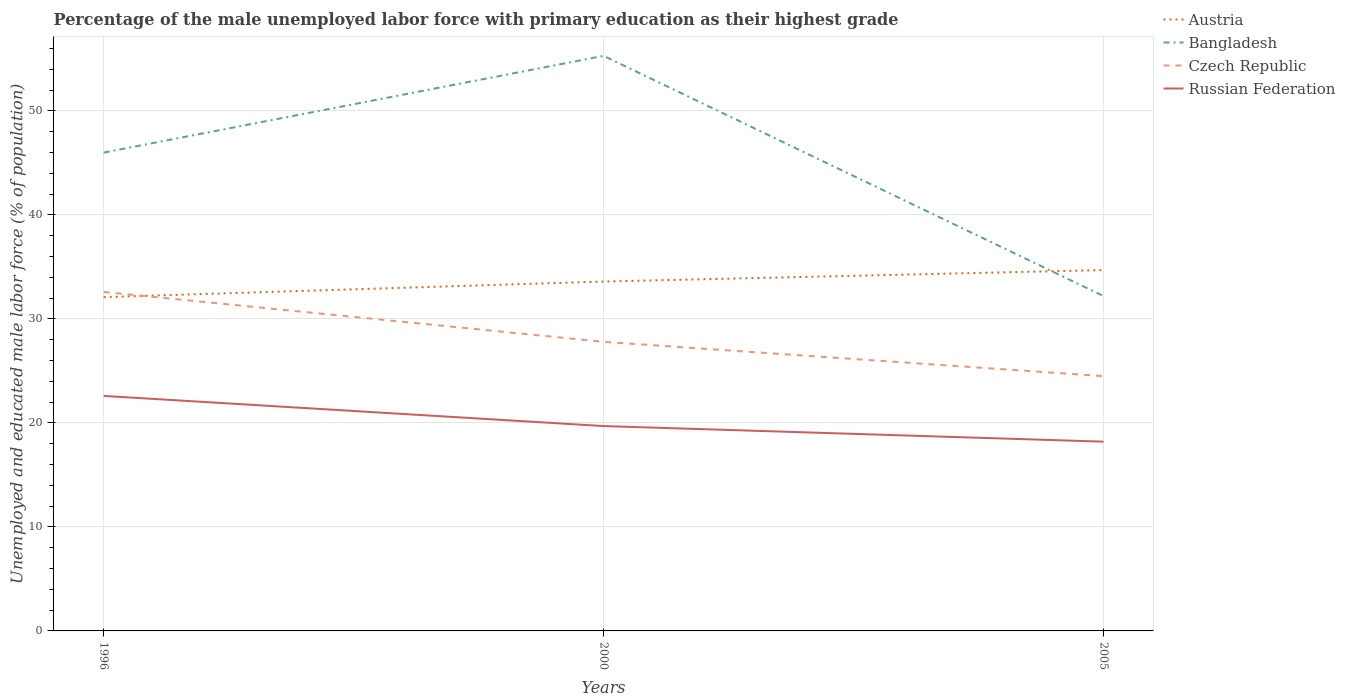How many different coloured lines are there?
Keep it short and to the point. 4. Does the line corresponding to Czech Republic intersect with the line corresponding to Austria?
Give a very brief answer. Yes. Across all years, what is the maximum percentage of the unemployed male labor force with primary education in Austria?
Your answer should be very brief. 32.1. What is the total percentage of the unemployed male labor force with primary education in Austria in the graph?
Your response must be concise. -2.6. What is the difference between the highest and the second highest percentage of the unemployed male labor force with primary education in Austria?
Keep it short and to the point. 2.6. What is the difference between the highest and the lowest percentage of the unemployed male labor force with primary education in Bangladesh?
Your response must be concise. 2. Is the percentage of the unemployed male labor force with primary education in Bangladesh strictly greater than the percentage of the unemployed male labor force with primary education in Austria over the years?
Your answer should be very brief. No. How many lines are there?
Provide a short and direct response. 4. How many years are there in the graph?
Your response must be concise. 3. What is the difference between two consecutive major ticks on the Y-axis?
Your answer should be very brief. 10. Does the graph contain grids?
Provide a short and direct response. Yes. How are the legend labels stacked?
Make the answer very short. Vertical. What is the title of the graph?
Provide a succinct answer. Percentage of the male unemployed labor force with primary education as their highest grade. What is the label or title of the X-axis?
Offer a terse response. Years. What is the label or title of the Y-axis?
Your response must be concise. Unemployed and educated male labor force (% of population). What is the Unemployed and educated male labor force (% of population) in Austria in 1996?
Your answer should be compact. 32.1. What is the Unemployed and educated male labor force (% of population) in Czech Republic in 1996?
Offer a terse response. 32.6. What is the Unemployed and educated male labor force (% of population) in Russian Federation in 1996?
Provide a succinct answer. 22.6. What is the Unemployed and educated male labor force (% of population) of Austria in 2000?
Provide a short and direct response. 33.6. What is the Unemployed and educated male labor force (% of population) in Bangladesh in 2000?
Keep it short and to the point. 55.3. What is the Unemployed and educated male labor force (% of population) in Czech Republic in 2000?
Your response must be concise. 27.8. What is the Unemployed and educated male labor force (% of population) of Russian Federation in 2000?
Ensure brevity in your answer.  19.7. What is the Unemployed and educated male labor force (% of population) in Austria in 2005?
Offer a very short reply. 34.7. What is the Unemployed and educated male labor force (% of population) in Bangladesh in 2005?
Ensure brevity in your answer.  32.2. What is the Unemployed and educated male labor force (% of population) of Czech Republic in 2005?
Make the answer very short. 24.5. What is the Unemployed and educated male labor force (% of population) of Russian Federation in 2005?
Provide a succinct answer. 18.2. Across all years, what is the maximum Unemployed and educated male labor force (% of population) of Austria?
Give a very brief answer. 34.7. Across all years, what is the maximum Unemployed and educated male labor force (% of population) of Bangladesh?
Your answer should be compact. 55.3. Across all years, what is the maximum Unemployed and educated male labor force (% of population) in Czech Republic?
Provide a short and direct response. 32.6. Across all years, what is the maximum Unemployed and educated male labor force (% of population) of Russian Federation?
Offer a terse response. 22.6. Across all years, what is the minimum Unemployed and educated male labor force (% of population) of Austria?
Make the answer very short. 32.1. Across all years, what is the minimum Unemployed and educated male labor force (% of population) in Bangladesh?
Make the answer very short. 32.2. Across all years, what is the minimum Unemployed and educated male labor force (% of population) of Russian Federation?
Your answer should be compact. 18.2. What is the total Unemployed and educated male labor force (% of population) in Austria in the graph?
Offer a terse response. 100.4. What is the total Unemployed and educated male labor force (% of population) in Bangladesh in the graph?
Offer a terse response. 133.5. What is the total Unemployed and educated male labor force (% of population) of Czech Republic in the graph?
Give a very brief answer. 84.9. What is the total Unemployed and educated male labor force (% of population) in Russian Federation in the graph?
Offer a terse response. 60.5. What is the difference between the Unemployed and educated male labor force (% of population) of Austria in 1996 and that in 2000?
Make the answer very short. -1.5. What is the difference between the Unemployed and educated male labor force (% of population) of Russian Federation in 1996 and that in 2000?
Give a very brief answer. 2.9. What is the difference between the Unemployed and educated male labor force (% of population) in Austria in 1996 and that in 2005?
Make the answer very short. -2.6. What is the difference between the Unemployed and educated male labor force (% of population) in Russian Federation in 1996 and that in 2005?
Keep it short and to the point. 4.4. What is the difference between the Unemployed and educated male labor force (% of population) of Austria in 2000 and that in 2005?
Keep it short and to the point. -1.1. What is the difference between the Unemployed and educated male labor force (% of population) in Bangladesh in 2000 and that in 2005?
Ensure brevity in your answer.  23.1. What is the difference between the Unemployed and educated male labor force (% of population) in Czech Republic in 2000 and that in 2005?
Keep it short and to the point. 3.3. What is the difference between the Unemployed and educated male labor force (% of population) in Russian Federation in 2000 and that in 2005?
Ensure brevity in your answer.  1.5. What is the difference between the Unemployed and educated male labor force (% of population) of Austria in 1996 and the Unemployed and educated male labor force (% of population) of Bangladesh in 2000?
Give a very brief answer. -23.2. What is the difference between the Unemployed and educated male labor force (% of population) in Austria in 1996 and the Unemployed and educated male labor force (% of population) in Czech Republic in 2000?
Offer a terse response. 4.3. What is the difference between the Unemployed and educated male labor force (% of population) in Austria in 1996 and the Unemployed and educated male labor force (% of population) in Russian Federation in 2000?
Provide a short and direct response. 12.4. What is the difference between the Unemployed and educated male labor force (% of population) in Bangladesh in 1996 and the Unemployed and educated male labor force (% of population) in Czech Republic in 2000?
Provide a short and direct response. 18.2. What is the difference between the Unemployed and educated male labor force (% of population) of Bangladesh in 1996 and the Unemployed and educated male labor force (% of population) of Russian Federation in 2000?
Your answer should be compact. 26.3. What is the difference between the Unemployed and educated male labor force (% of population) in Czech Republic in 1996 and the Unemployed and educated male labor force (% of population) in Russian Federation in 2000?
Provide a succinct answer. 12.9. What is the difference between the Unemployed and educated male labor force (% of population) in Austria in 1996 and the Unemployed and educated male labor force (% of population) in Bangladesh in 2005?
Offer a terse response. -0.1. What is the difference between the Unemployed and educated male labor force (% of population) in Bangladesh in 1996 and the Unemployed and educated male labor force (% of population) in Czech Republic in 2005?
Provide a succinct answer. 21.5. What is the difference between the Unemployed and educated male labor force (% of population) in Bangladesh in 1996 and the Unemployed and educated male labor force (% of population) in Russian Federation in 2005?
Offer a very short reply. 27.8. What is the difference between the Unemployed and educated male labor force (% of population) of Czech Republic in 1996 and the Unemployed and educated male labor force (% of population) of Russian Federation in 2005?
Your answer should be compact. 14.4. What is the difference between the Unemployed and educated male labor force (% of population) in Austria in 2000 and the Unemployed and educated male labor force (% of population) in Czech Republic in 2005?
Keep it short and to the point. 9.1. What is the difference between the Unemployed and educated male labor force (% of population) in Bangladesh in 2000 and the Unemployed and educated male labor force (% of population) in Czech Republic in 2005?
Keep it short and to the point. 30.8. What is the difference between the Unemployed and educated male labor force (% of population) in Bangladesh in 2000 and the Unemployed and educated male labor force (% of population) in Russian Federation in 2005?
Ensure brevity in your answer.  37.1. What is the average Unemployed and educated male labor force (% of population) in Austria per year?
Your answer should be compact. 33.47. What is the average Unemployed and educated male labor force (% of population) of Bangladesh per year?
Give a very brief answer. 44.5. What is the average Unemployed and educated male labor force (% of population) in Czech Republic per year?
Make the answer very short. 28.3. What is the average Unemployed and educated male labor force (% of population) of Russian Federation per year?
Keep it short and to the point. 20.17. In the year 1996, what is the difference between the Unemployed and educated male labor force (% of population) of Austria and Unemployed and educated male labor force (% of population) of Bangladesh?
Offer a very short reply. -13.9. In the year 1996, what is the difference between the Unemployed and educated male labor force (% of population) in Bangladesh and Unemployed and educated male labor force (% of population) in Russian Federation?
Your answer should be compact. 23.4. In the year 2000, what is the difference between the Unemployed and educated male labor force (% of population) in Austria and Unemployed and educated male labor force (% of population) in Bangladesh?
Give a very brief answer. -21.7. In the year 2000, what is the difference between the Unemployed and educated male labor force (% of population) in Austria and Unemployed and educated male labor force (% of population) in Czech Republic?
Ensure brevity in your answer.  5.8. In the year 2000, what is the difference between the Unemployed and educated male labor force (% of population) of Bangladesh and Unemployed and educated male labor force (% of population) of Russian Federation?
Keep it short and to the point. 35.6. In the year 2005, what is the difference between the Unemployed and educated male labor force (% of population) in Bangladesh and Unemployed and educated male labor force (% of population) in Czech Republic?
Give a very brief answer. 7.7. In the year 2005, what is the difference between the Unemployed and educated male labor force (% of population) in Bangladesh and Unemployed and educated male labor force (% of population) in Russian Federation?
Your response must be concise. 14. In the year 2005, what is the difference between the Unemployed and educated male labor force (% of population) of Czech Republic and Unemployed and educated male labor force (% of population) of Russian Federation?
Offer a very short reply. 6.3. What is the ratio of the Unemployed and educated male labor force (% of population) of Austria in 1996 to that in 2000?
Keep it short and to the point. 0.96. What is the ratio of the Unemployed and educated male labor force (% of population) of Bangladesh in 1996 to that in 2000?
Ensure brevity in your answer.  0.83. What is the ratio of the Unemployed and educated male labor force (% of population) of Czech Republic in 1996 to that in 2000?
Provide a short and direct response. 1.17. What is the ratio of the Unemployed and educated male labor force (% of population) in Russian Federation in 1996 to that in 2000?
Give a very brief answer. 1.15. What is the ratio of the Unemployed and educated male labor force (% of population) of Austria in 1996 to that in 2005?
Ensure brevity in your answer.  0.93. What is the ratio of the Unemployed and educated male labor force (% of population) of Bangladesh in 1996 to that in 2005?
Provide a succinct answer. 1.43. What is the ratio of the Unemployed and educated male labor force (% of population) of Czech Republic in 1996 to that in 2005?
Offer a terse response. 1.33. What is the ratio of the Unemployed and educated male labor force (% of population) of Russian Federation in 1996 to that in 2005?
Provide a succinct answer. 1.24. What is the ratio of the Unemployed and educated male labor force (% of population) of Austria in 2000 to that in 2005?
Give a very brief answer. 0.97. What is the ratio of the Unemployed and educated male labor force (% of population) in Bangladesh in 2000 to that in 2005?
Provide a short and direct response. 1.72. What is the ratio of the Unemployed and educated male labor force (% of population) of Czech Republic in 2000 to that in 2005?
Offer a terse response. 1.13. What is the ratio of the Unemployed and educated male labor force (% of population) of Russian Federation in 2000 to that in 2005?
Your answer should be compact. 1.08. What is the difference between the highest and the second highest Unemployed and educated male labor force (% of population) of Austria?
Keep it short and to the point. 1.1. What is the difference between the highest and the second highest Unemployed and educated male labor force (% of population) in Czech Republic?
Ensure brevity in your answer.  4.8. What is the difference between the highest and the second highest Unemployed and educated male labor force (% of population) in Russian Federation?
Provide a succinct answer. 2.9. What is the difference between the highest and the lowest Unemployed and educated male labor force (% of population) in Bangladesh?
Your answer should be very brief. 23.1. 